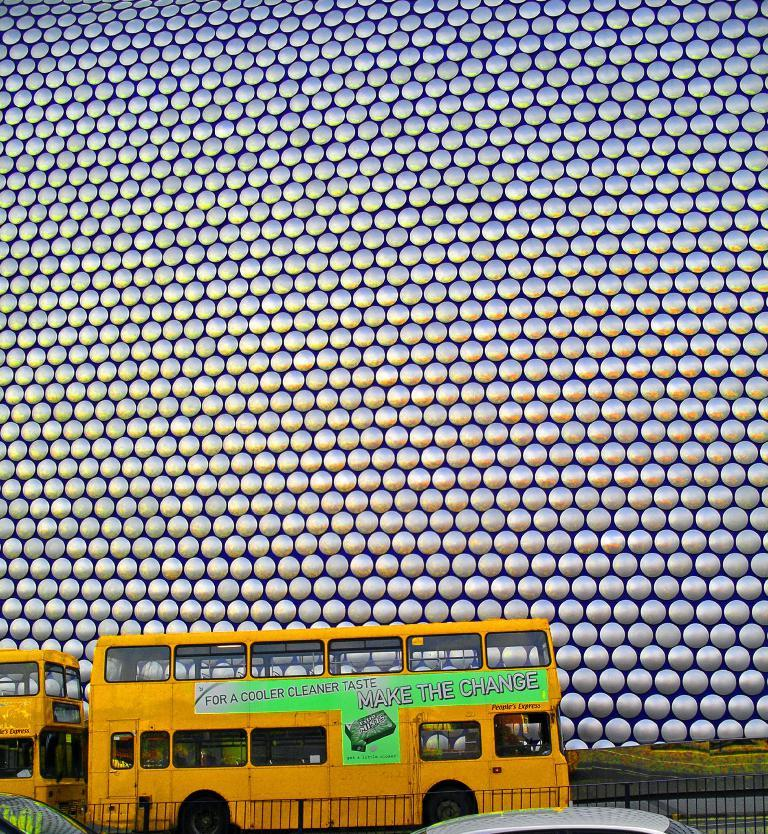What type of vehicles can be seen in the image? There are buses in the image. What is written on the buses? There is text on the buses. What can be seen in the background of the image? There is a wall visible in the background of the image. What is present at the bottom of the image? There is railing at the bottom of the image. What other types of vehicles are present in the image? There are other vehicles in the image. What type of wood can be seen in the image? There is no wood present in the image. What is the engine of the bus like in the image? The image does not show the engine of the bus, so it cannot be described. 